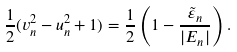Convert formula to latex. <formula><loc_0><loc_0><loc_500><loc_500>\frac { 1 } { 2 } ( v _ { n } ^ { 2 } - u _ { n } ^ { 2 } + 1 ) = \frac { 1 } { 2 } \left ( 1 - \frac { \tilde { \varepsilon } _ { n } } { | E _ { n } | } \right ) .</formula> 